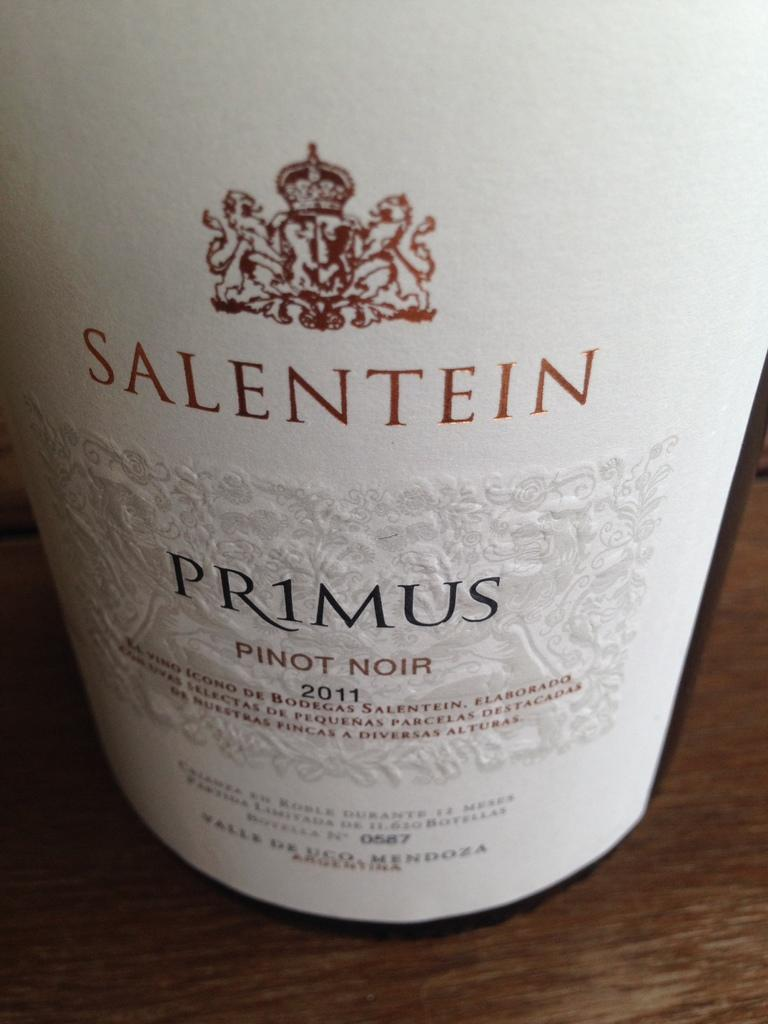<image>
Offer a succinct explanation of the picture presented. a bottle of pino nior from 2011 is sitting on a table 